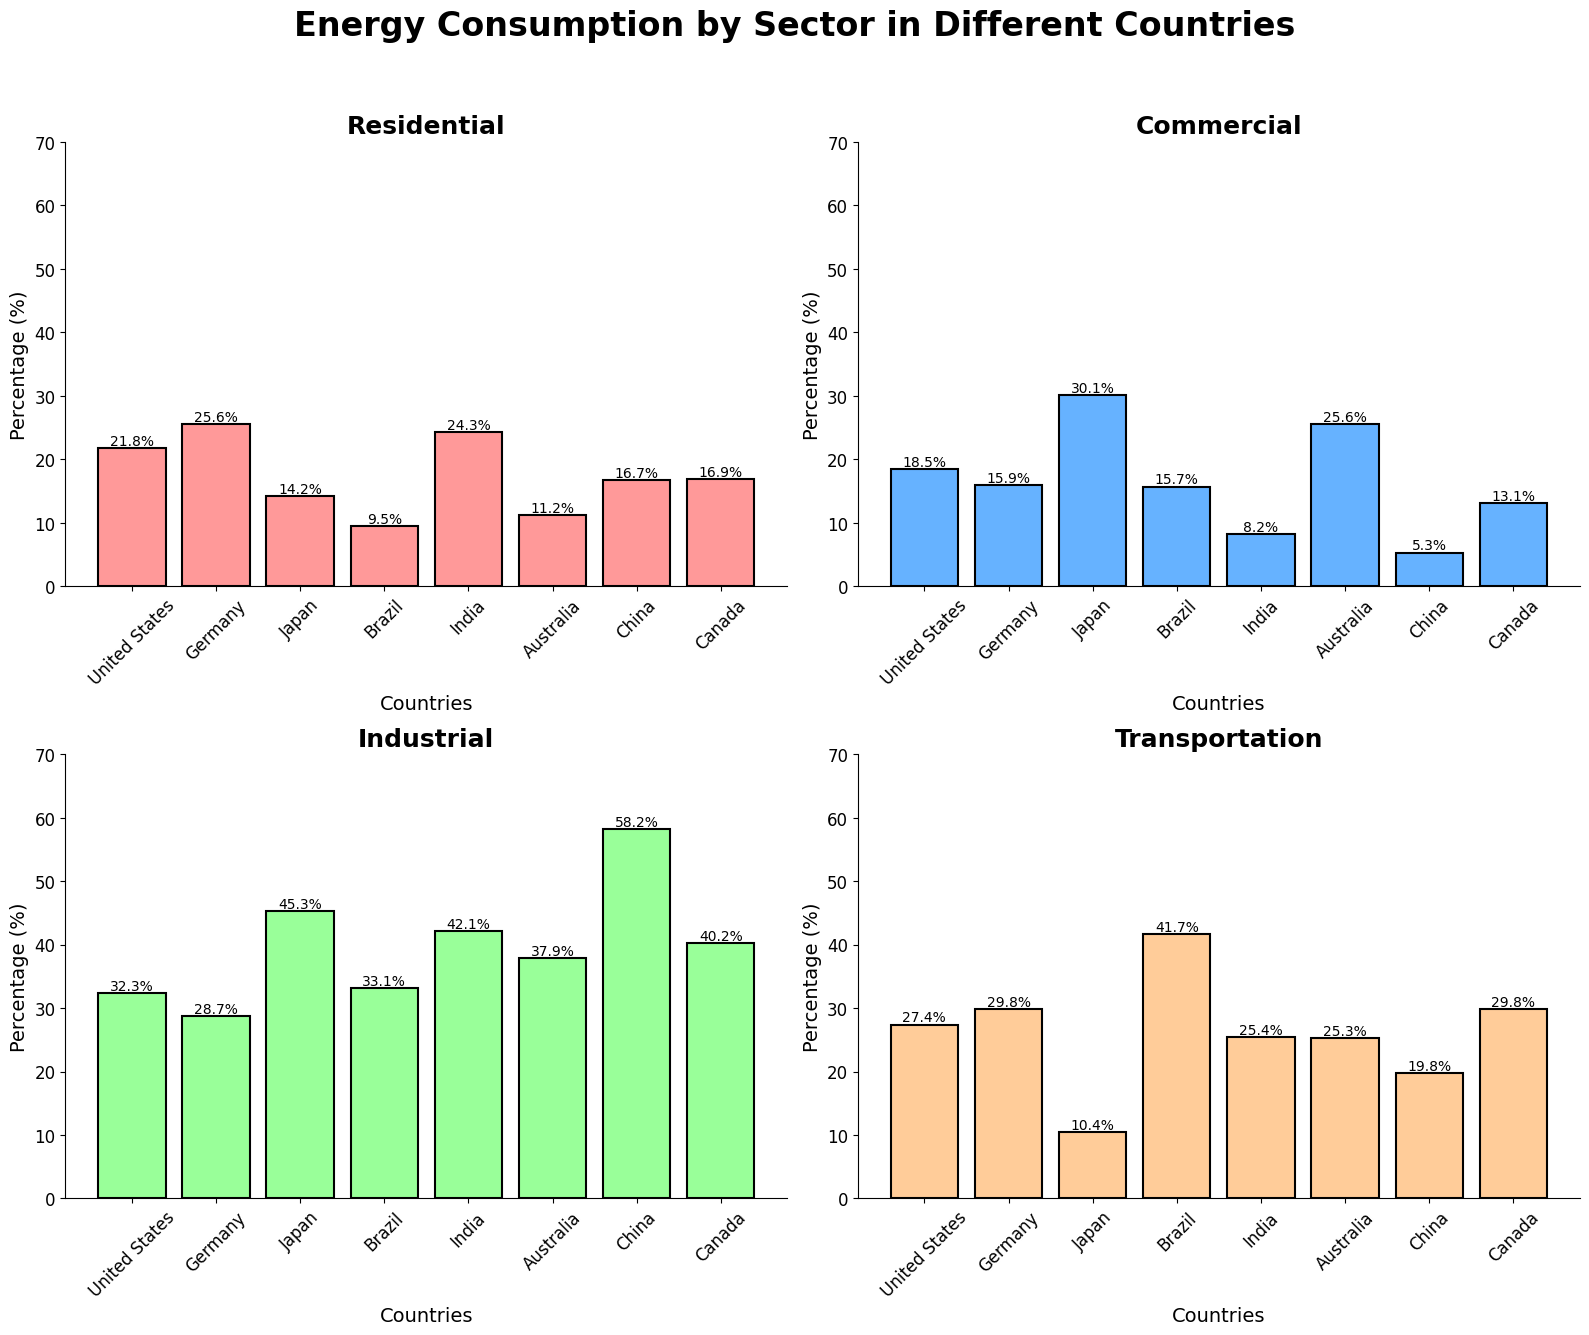what sector has the highest energy consumption in the United States? In the subplot for each sector, look for the highest bar labeled 'United States'. The sector that corresponds to this bar represents the highest energy consumption. The highest bar in the United States is in the 'Industrial' subplot at 32.3%.
Answer: Industrial what is the difference in residential energy consumption between Germany and China? Refer to the Residential subplot. Find the height of the bars for Germany (25.6%) and China (16.7%), then calculate the difference: 25.6% - 16.7% = 8.9%.
Answer: 8.9% which country has the lowest commercial energy consumption? Look at the Commercial subplot and identify the shortest bar. The bar for China is the shortest, and it represents 5.3%.
Answer: China how much more industrial energy does Japan consume compared to Brazil? Refer to the Industrial subplot and find the values for Japan (45.3%) and Brazil (33.1%). Subtract Brazil's consumption from Japan's: 45.3% - 33.1% = 12.2%.
Answer: 12.2% which two countries have equal transportation energy consumption percentages? Look at the Transportation subplot and identify bars with the same height. Both Germany and Canada have bars at 29.8%.
Answer: Germany and Canada what is the average commercial energy consumption across all the countries? From the Commercial subplot, sum the percentages: 18.5% + 15.9% + 30.1% + 15.7% + 8.2% + 25.6% + 5.3% + 13.1% = 132.4%. Then, divide by the number of countries (8): 132.4 / 8 = 16.55%.
Answer: 16.55% what percentage of China's total energy consumption (across all sectors) is used for transportation? Find the individual percentages for China in each subplot and sum them: 16.7% + 5.3% + 58.2% + 19.8% = 100%. Then, calculate the percentage out of the total for transportation: (19.8 / 100) * 100% = 19.8%.
Answer: 19.8% in which sector does Brazil have the highest energy consumption? Analyze the subplots for Brazil and identify the highest bar overall. Brazil's highest consumption is in the Transportation sector at 41.7%.
Answer: Transportation how does Australia's residential energy consumption compare to its industrial energy consumption? Look at Australia's bars in the Residential (11.2%) and Industrial (37.9%) subplots. Australia's residential energy consumption is lower than its industrial energy consumption.
Answer: Lower what is the combined industrial energy consumption for the United States and Canada? Refer to the Industrial subplot. The values for the United States and Canada are 32.3% and 40.2% respectively. Add these together: 32.3% + 40.2% = 72.5%.
Answer: 72.5% 